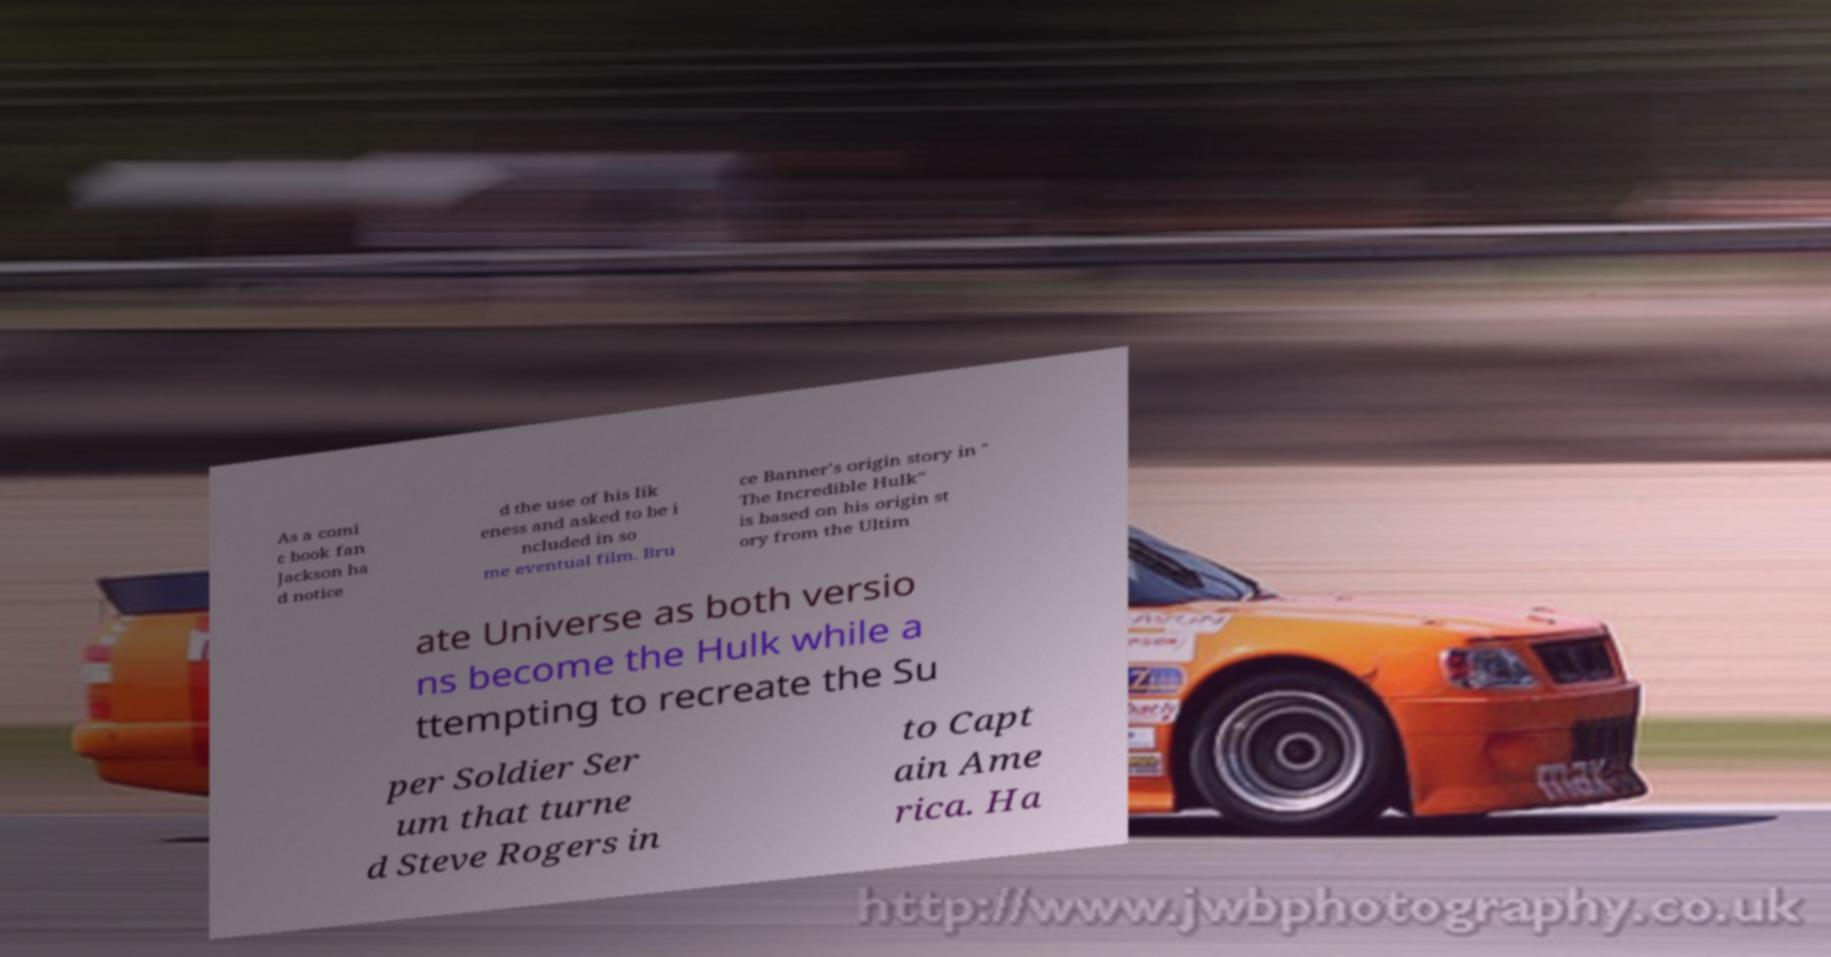Can you accurately transcribe the text from the provided image for me? As a comi c book fan Jackson ha d notice d the use of his lik eness and asked to be i ncluded in so me eventual film. Bru ce Banner's origin story in " The Incredible Hulk" is based on his origin st ory from the Ultim ate Universe as both versio ns become the Hulk while a ttempting to recreate the Su per Soldier Ser um that turne d Steve Rogers in to Capt ain Ame rica. Ha 